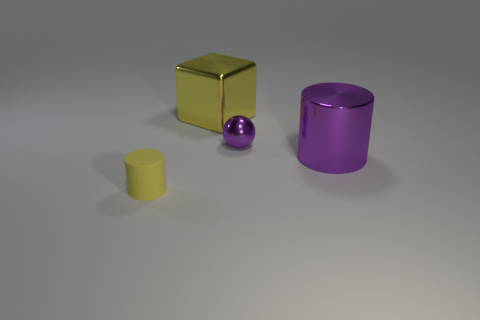Add 2 yellow cubes. How many objects exist? 6 Subtract all balls. How many objects are left? 3 Add 4 large yellow things. How many large yellow things exist? 5 Subtract 0 red blocks. How many objects are left? 4 Subtract all big cyan metal things. Subtract all small purple metal balls. How many objects are left? 3 Add 2 large purple things. How many large purple things are left? 3 